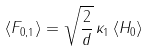<formula> <loc_0><loc_0><loc_500><loc_500>\langle F _ { 0 , 1 } \rangle = \sqrt { \frac { 2 } { d } } \, \kappa _ { 1 } \, \langle H _ { 0 } \rangle</formula> 